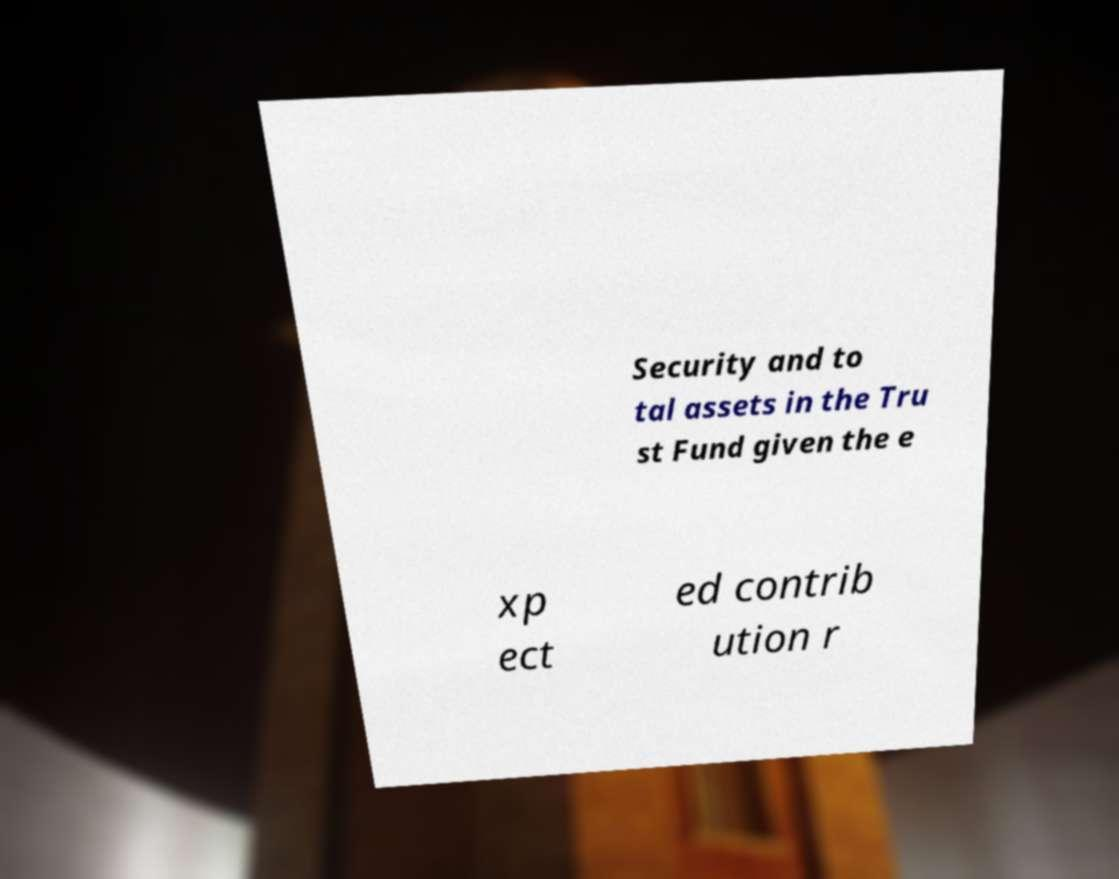Please read and relay the text visible in this image. What does it say? Security and to tal assets in the Tru st Fund given the e xp ect ed contrib ution r 